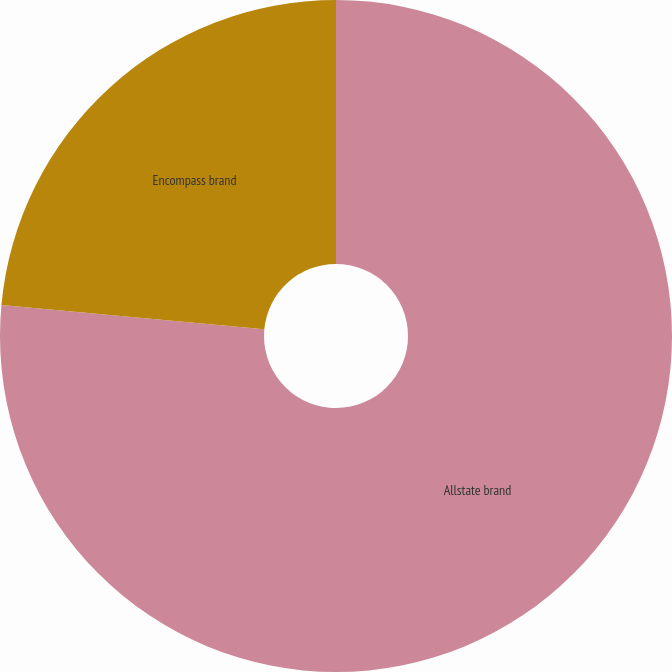Convert chart to OTSL. <chart><loc_0><loc_0><loc_500><loc_500><pie_chart><fcel>Allstate brand<fcel>Encompass brand<nl><fcel>76.47%<fcel>23.53%<nl></chart> 